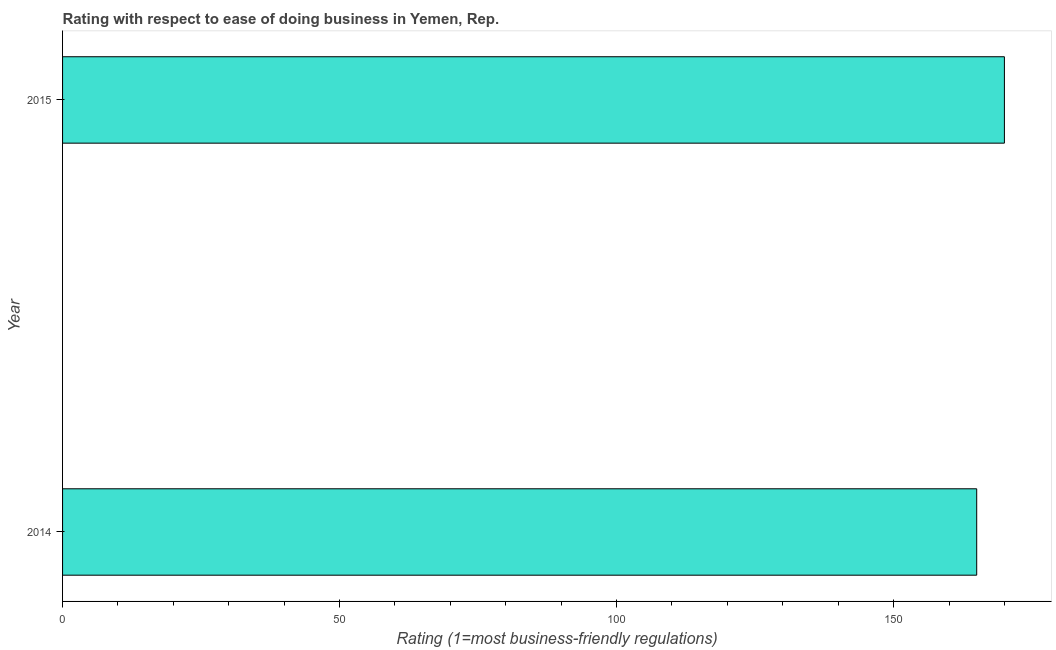Does the graph contain grids?
Offer a terse response. No. What is the title of the graph?
Keep it short and to the point. Rating with respect to ease of doing business in Yemen, Rep. What is the label or title of the X-axis?
Keep it short and to the point. Rating (1=most business-friendly regulations). What is the label or title of the Y-axis?
Ensure brevity in your answer.  Year. What is the ease of doing business index in 2014?
Offer a very short reply. 165. Across all years, what is the maximum ease of doing business index?
Your response must be concise. 170. Across all years, what is the minimum ease of doing business index?
Your answer should be very brief. 165. In which year was the ease of doing business index maximum?
Make the answer very short. 2015. What is the sum of the ease of doing business index?
Your answer should be very brief. 335. What is the average ease of doing business index per year?
Ensure brevity in your answer.  167. What is the median ease of doing business index?
Your answer should be very brief. 167.5. In how many years, is the ease of doing business index greater than 40 ?
Offer a very short reply. 2. Do a majority of the years between 2015 and 2014 (inclusive) have ease of doing business index greater than 70 ?
Give a very brief answer. No. Is the ease of doing business index in 2014 less than that in 2015?
Keep it short and to the point. Yes. In how many years, is the ease of doing business index greater than the average ease of doing business index taken over all years?
Provide a short and direct response. 1. How many bars are there?
Offer a very short reply. 2. How many years are there in the graph?
Ensure brevity in your answer.  2. What is the Rating (1=most business-friendly regulations) of 2014?
Keep it short and to the point. 165. What is the Rating (1=most business-friendly regulations) of 2015?
Provide a succinct answer. 170. What is the ratio of the Rating (1=most business-friendly regulations) in 2014 to that in 2015?
Offer a very short reply. 0.97. 